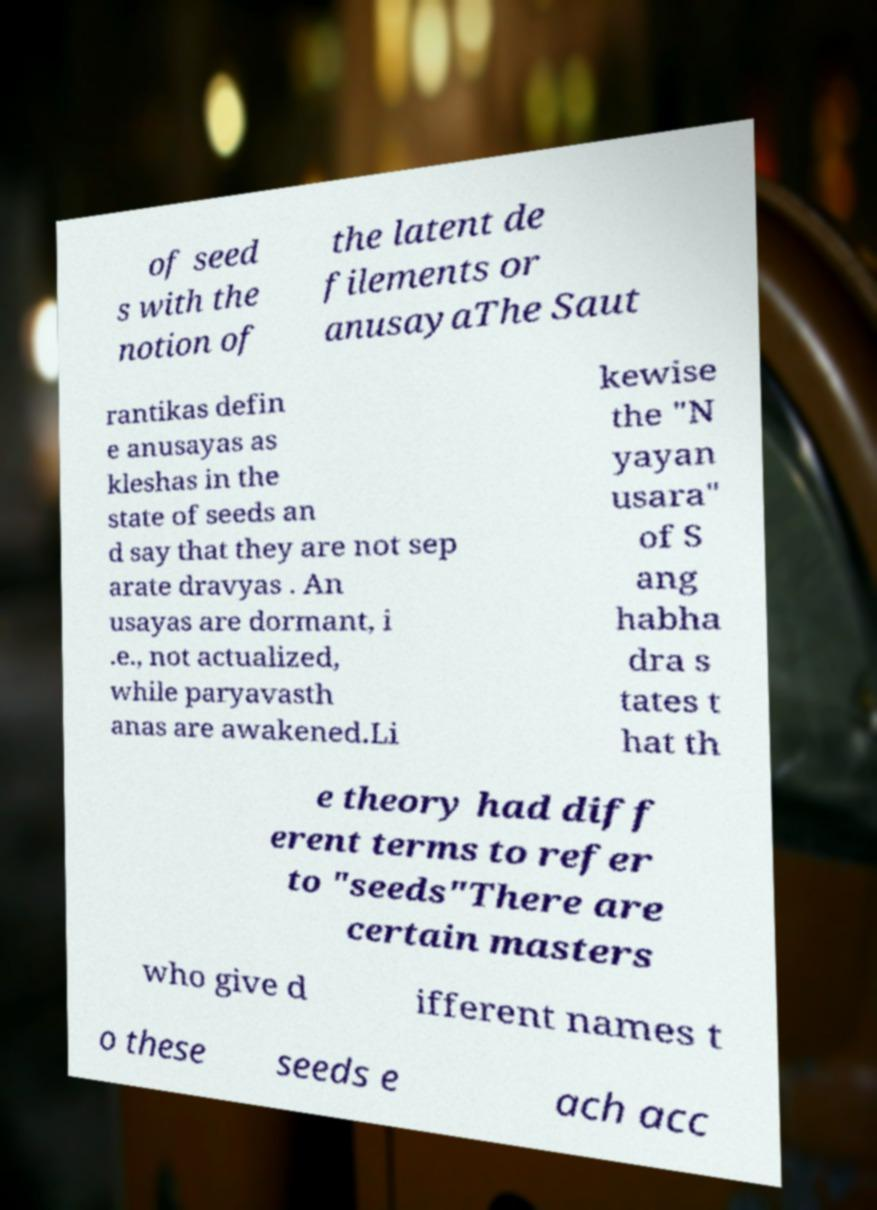Can you accurately transcribe the text from the provided image for me? of seed s with the notion of the latent de filements or anusayaThe Saut rantikas defin e anusayas as kleshas in the state of seeds an d say that they are not sep arate dravyas . An usayas are dormant, i .e., not actualized, while paryavasth anas are awakened.Li kewise the "N yayan usara" of S ang habha dra s tates t hat th e theory had diff erent terms to refer to "seeds"There are certain masters who give d ifferent names t o these seeds e ach acc 